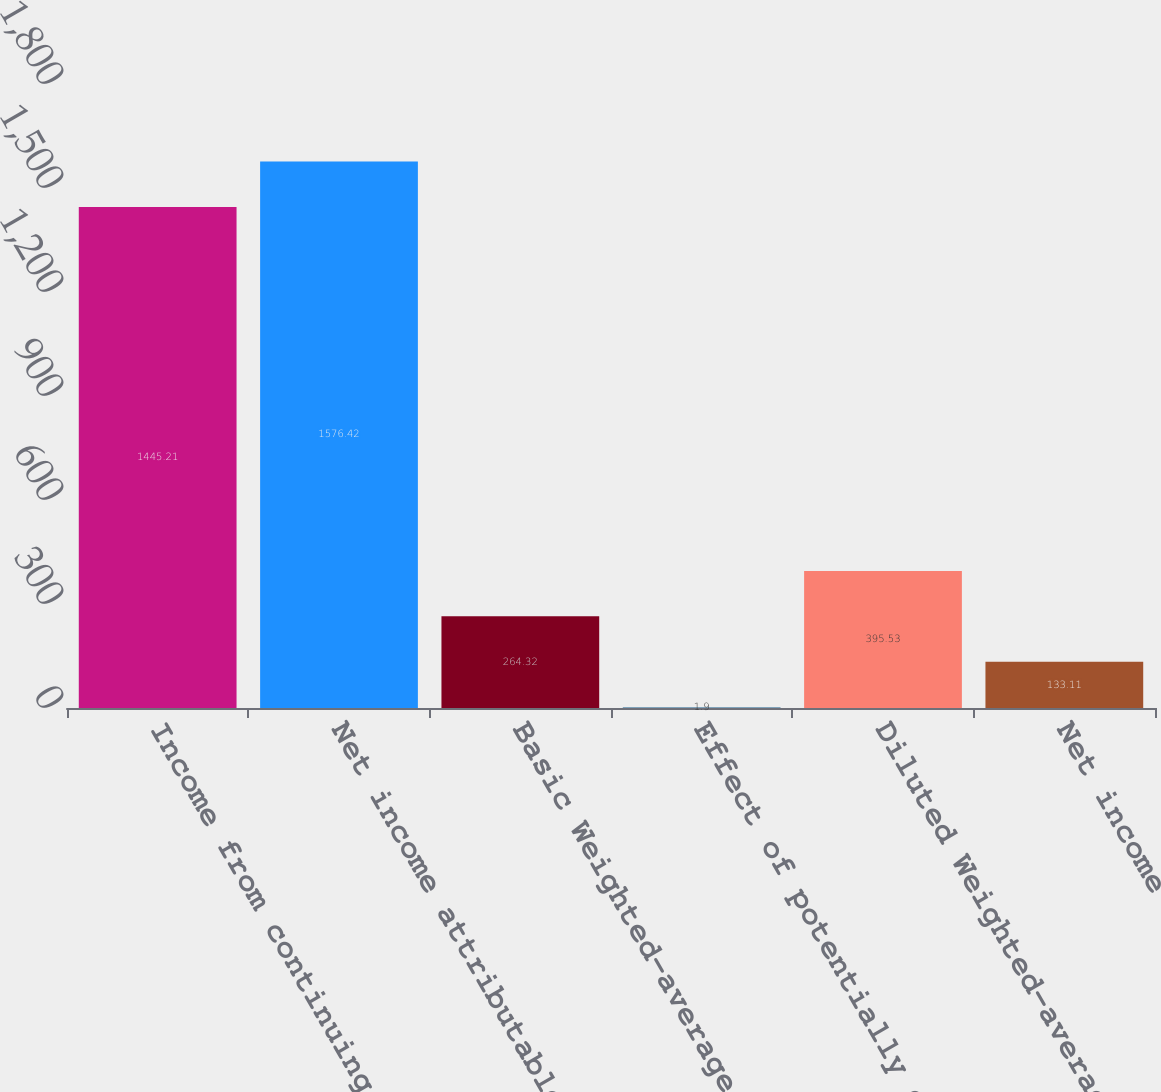<chart> <loc_0><loc_0><loc_500><loc_500><bar_chart><fcel>Income from continuing<fcel>Net income attributable to<fcel>Basic Weighted-average common<fcel>Effect of potentially dilutive<fcel>Diluted Weighted-average<fcel>Net income<nl><fcel>1445.21<fcel>1576.42<fcel>264.32<fcel>1.9<fcel>395.53<fcel>133.11<nl></chart> 